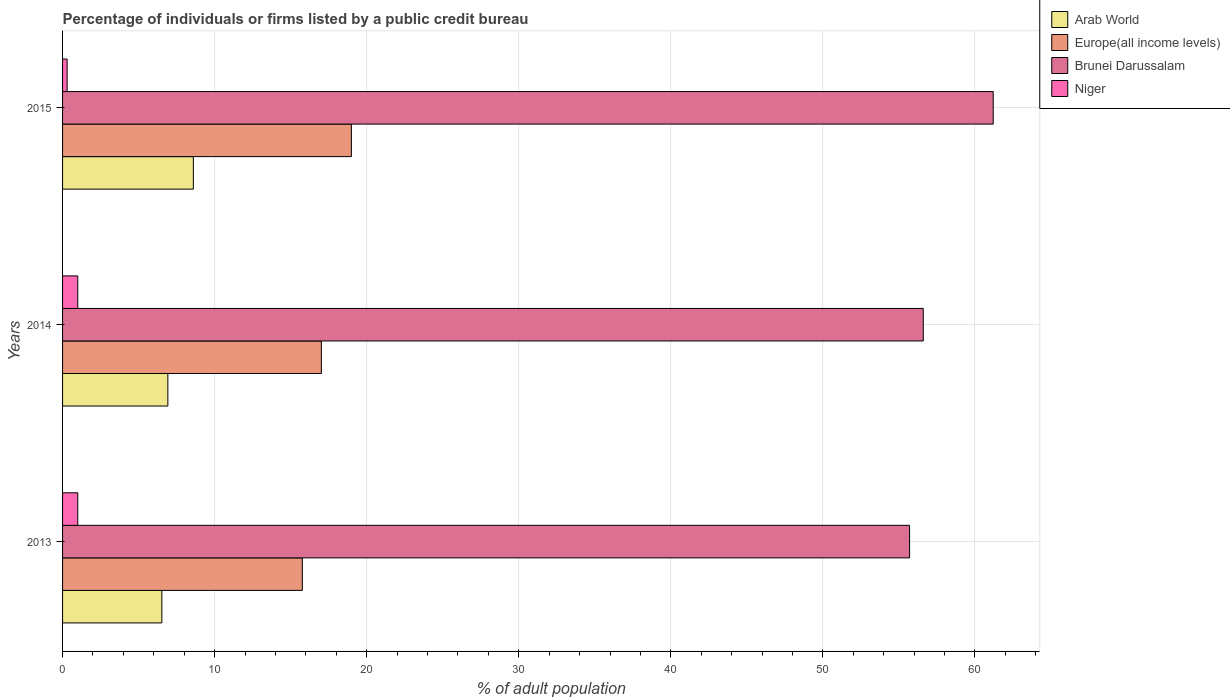Are the number of bars on each tick of the Y-axis equal?
Give a very brief answer. Yes. How many bars are there on the 1st tick from the bottom?
Offer a terse response. 4. In how many cases, is the number of bars for a given year not equal to the number of legend labels?
Give a very brief answer. 0. What is the percentage of population listed by a public credit bureau in Brunei Darussalam in 2013?
Provide a short and direct response. 55.7. Across all years, what is the maximum percentage of population listed by a public credit bureau in Europe(all income levels)?
Your answer should be compact. 18.99. Across all years, what is the minimum percentage of population listed by a public credit bureau in Europe(all income levels)?
Ensure brevity in your answer.  15.77. In which year was the percentage of population listed by a public credit bureau in Arab World maximum?
Provide a succinct answer. 2015. In which year was the percentage of population listed by a public credit bureau in Niger minimum?
Offer a terse response. 2015. What is the total percentage of population listed by a public credit bureau in Brunei Darussalam in the graph?
Provide a succinct answer. 173.5. What is the difference between the percentage of population listed by a public credit bureau in Europe(all income levels) in 2013 and that in 2015?
Provide a short and direct response. -3.23. What is the average percentage of population listed by a public credit bureau in Arab World per year?
Give a very brief answer. 7.35. In the year 2015, what is the difference between the percentage of population listed by a public credit bureau in Europe(all income levels) and percentage of population listed by a public credit bureau in Arab World?
Offer a terse response. 10.39. In how many years, is the percentage of population listed by a public credit bureau in Arab World greater than 22 %?
Provide a succinct answer. 0. What is the ratio of the percentage of population listed by a public credit bureau in Brunei Darussalam in 2014 to that in 2015?
Offer a terse response. 0.92. Is the percentage of population listed by a public credit bureau in Europe(all income levels) in 2013 less than that in 2014?
Your response must be concise. Yes. What is the difference between the highest and the second highest percentage of population listed by a public credit bureau in Europe(all income levels)?
Your response must be concise. 1.98. What is the difference between the highest and the lowest percentage of population listed by a public credit bureau in Brunei Darussalam?
Offer a terse response. 5.5. In how many years, is the percentage of population listed by a public credit bureau in Europe(all income levels) greater than the average percentage of population listed by a public credit bureau in Europe(all income levels) taken over all years?
Your response must be concise. 1. Is it the case that in every year, the sum of the percentage of population listed by a public credit bureau in Brunei Darussalam and percentage of population listed by a public credit bureau in Niger is greater than the sum of percentage of population listed by a public credit bureau in Europe(all income levels) and percentage of population listed by a public credit bureau in Arab World?
Provide a short and direct response. Yes. What does the 3rd bar from the top in 2015 represents?
Your answer should be compact. Europe(all income levels). What does the 3rd bar from the bottom in 2014 represents?
Your answer should be very brief. Brunei Darussalam. Is it the case that in every year, the sum of the percentage of population listed by a public credit bureau in Europe(all income levels) and percentage of population listed by a public credit bureau in Arab World is greater than the percentage of population listed by a public credit bureau in Niger?
Ensure brevity in your answer.  Yes. How many bars are there?
Your response must be concise. 12. Are all the bars in the graph horizontal?
Offer a very short reply. Yes. How many years are there in the graph?
Offer a very short reply. 3. What is the difference between two consecutive major ticks on the X-axis?
Offer a very short reply. 10. Are the values on the major ticks of X-axis written in scientific E-notation?
Give a very brief answer. No. Does the graph contain grids?
Your response must be concise. Yes. What is the title of the graph?
Offer a very short reply. Percentage of individuals or firms listed by a public credit bureau. Does "Swaziland" appear as one of the legend labels in the graph?
Your answer should be very brief. No. What is the label or title of the X-axis?
Offer a very short reply. % of adult population. What is the label or title of the Y-axis?
Your answer should be very brief. Years. What is the % of adult population in Arab World in 2013?
Make the answer very short. 6.53. What is the % of adult population in Europe(all income levels) in 2013?
Ensure brevity in your answer.  15.77. What is the % of adult population in Brunei Darussalam in 2013?
Give a very brief answer. 55.7. What is the % of adult population of Arab World in 2014?
Your answer should be very brief. 6.92. What is the % of adult population in Europe(all income levels) in 2014?
Give a very brief answer. 17.02. What is the % of adult population of Brunei Darussalam in 2014?
Ensure brevity in your answer.  56.6. What is the % of adult population of Niger in 2014?
Your response must be concise. 1. What is the % of adult population in Arab World in 2015?
Provide a succinct answer. 8.6. What is the % of adult population of Europe(all income levels) in 2015?
Keep it short and to the point. 18.99. What is the % of adult population of Brunei Darussalam in 2015?
Your answer should be very brief. 61.2. Across all years, what is the maximum % of adult population of Europe(all income levels)?
Make the answer very short. 18.99. Across all years, what is the maximum % of adult population of Brunei Darussalam?
Make the answer very short. 61.2. Across all years, what is the minimum % of adult population in Arab World?
Provide a short and direct response. 6.53. Across all years, what is the minimum % of adult population of Europe(all income levels)?
Ensure brevity in your answer.  15.77. Across all years, what is the minimum % of adult population of Brunei Darussalam?
Your response must be concise. 55.7. Across all years, what is the minimum % of adult population in Niger?
Your answer should be compact. 0.3. What is the total % of adult population of Arab World in the graph?
Give a very brief answer. 22.05. What is the total % of adult population in Europe(all income levels) in the graph?
Offer a very short reply. 51.78. What is the total % of adult population in Brunei Darussalam in the graph?
Offer a terse response. 173.5. What is the difference between the % of adult population of Arab World in 2013 and that in 2014?
Your answer should be compact. -0.4. What is the difference between the % of adult population in Europe(all income levels) in 2013 and that in 2014?
Your answer should be compact. -1.25. What is the difference between the % of adult population of Brunei Darussalam in 2013 and that in 2014?
Offer a terse response. -0.9. What is the difference between the % of adult population in Arab World in 2013 and that in 2015?
Offer a terse response. -2.07. What is the difference between the % of adult population of Europe(all income levels) in 2013 and that in 2015?
Give a very brief answer. -3.23. What is the difference between the % of adult population in Niger in 2013 and that in 2015?
Provide a short and direct response. 0.7. What is the difference between the % of adult population in Arab World in 2014 and that in 2015?
Provide a succinct answer. -1.68. What is the difference between the % of adult population in Europe(all income levels) in 2014 and that in 2015?
Ensure brevity in your answer.  -1.98. What is the difference between the % of adult population of Niger in 2014 and that in 2015?
Your answer should be very brief. 0.7. What is the difference between the % of adult population of Arab World in 2013 and the % of adult population of Europe(all income levels) in 2014?
Offer a terse response. -10.49. What is the difference between the % of adult population of Arab World in 2013 and the % of adult population of Brunei Darussalam in 2014?
Your answer should be very brief. -50.07. What is the difference between the % of adult population of Arab World in 2013 and the % of adult population of Niger in 2014?
Provide a short and direct response. 5.53. What is the difference between the % of adult population in Europe(all income levels) in 2013 and the % of adult population in Brunei Darussalam in 2014?
Your answer should be very brief. -40.83. What is the difference between the % of adult population of Europe(all income levels) in 2013 and the % of adult population of Niger in 2014?
Offer a very short reply. 14.77. What is the difference between the % of adult population of Brunei Darussalam in 2013 and the % of adult population of Niger in 2014?
Ensure brevity in your answer.  54.7. What is the difference between the % of adult population of Arab World in 2013 and the % of adult population of Europe(all income levels) in 2015?
Your answer should be compact. -12.47. What is the difference between the % of adult population of Arab World in 2013 and the % of adult population of Brunei Darussalam in 2015?
Provide a succinct answer. -54.67. What is the difference between the % of adult population of Arab World in 2013 and the % of adult population of Niger in 2015?
Offer a very short reply. 6.23. What is the difference between the % of adult population in Europe(all income levels) in 2013 and the % of adult population in Brunei Darussalam in 2015?
Provide a succinct answer. -45.43. What is the difference between the % of adult population of Europe(all income levels) in 2013 and the % of adult population of Niger in 2015?
Your response must be concise. 15.47. What is the difference between the % of adult population of Brunei Darussalam in 2013 and the % of adult population of Niger in 2015?
Provide a succinct answer. 55.4. What is the difference between the % of adult population in Arab World in 2014 and the % of adult population in Europe(all income levels) in 2015?
Provide a short and direct response. -12.07. What is the difference between the % of adult population in Arab World in 2014 and the % of adult population in Brunei Darussalam in 2015?
Ensure brevity in your answer.  -54.28. What is the difference between the % of adult population in Arab World in 2014 and the % of adult population in Niger in 2015?
Keep it short and to the point. 6.62. What is the difference between the % of adult population in Europe(all income levels) in 2014 and the % of adult population in Brunei Darussalam in 2015?
Your answer should be compact. -44.18. What is the difference between the % of adult population in Europe(all income levels) in 2014 and the % of adult population in Niger in 2015?
Offer a terse response. 16.72. What is the difference between the % of adult population in Brunei Darussalam in 2014 and the % of adult population in Niger in 2015?
Your answer should be very brief. 56.3. What is the average % of adult population in Arab World per year?
Keep it short and to the point. 7.35. What is the average % of adult population in Europe(all income levels) per year?
Provide a short and direct response. 17.26. What is the average % of adult population of Brunei Darussalam per year?
Make the answer very short. 57.83. What is the average % of adult population in Niger per year?
Offer a terse response. 0.77. In the year 2013, what is the difference between the % of adult population of Arab World and % of adult population of Europe(all income levels)?
Your answer should be very brief. -9.24. In the year 2013, what is the difference between the % of adult population in Arab World and % of adult population in Brunei Darussalam?
Ensure brevity in your answer.  -49.17. In the year 2013, what is the difference between the % of adult population of Arab World and % of adult population of Niger?
Your response must be concise. 5.53. In the year 2013, what is the difference between the % of adult population in Europe(all income levels) and % of adult population in Brunei Darussalam?
Ensure brevity in your answer.  -39.93. In the year 2013, what is the difference between the % of adult population in Europe(all income levels) and % of adult population in Niger?
Make the answer very short. 14.77. In the year 2013, what is the difference between the % of adult population of Brunei Darussalam and % of adult population of Niger?
Your answer should be compact. 54.7. In the year 2014, what is the difference between the % of adult population in Arab World and % of adult population in Europe(all income levels)?
Your response must be concise. -10.09. In the year 2014, what is the difference between the % of adult population in Arab World and % of adult population in Brunei Darussalam?
Keep it short and to the point. -49.68. In the year 2014, what is the difference between the % of adult population of Arab World and % of adult population of Niger?
Ensure brevity in your answer.  5.92. In the year 2014, what is the difference between the % of adult population of Europe(all income levels) and % of adult population of Brunei Darussalam?
Provide a short and direct response. -39.58. In the year 2014, what is the difference between the % of adult population of Europe(all income levels) and % of adult population of Niger?
Your response must be concise. 16.02. In the year 2014, what is the difference between the % of adult population in Brunei Darussalam and % of adult population in Niger?
Ensure brevity in your answer.  55.6. In the year 2015, what is the difference between the % of adult population in Arab World and % of adult population in Europe(all income levels)?
Make the answer very short. -10.39. In the year 2015, what is the difference between the % of adult population of Arab World and % of adult population of Brunei Darussalam?
Provide a short and direct response. -52.6. In the year 2015, what is the difference between the % of adult population in Arab World and % of adult population in Niger?
Your response must be concise. 8.3. In the year 2015, what is the difference between the % of adult population in Europe(all income levels) and % of adult population in Brunei Darussalam?
Your response must be concise. -42.21. In the year 2015, what is the difference between the % of adult population in Europe(all income levels) and % of adult population in Niger?
Keep it short and to the point. 18.69. In the year 2015, what is the difference between the % of adult population of Brunei Darussalam and % of adult population of Niger?
Your answer should be very brief. 60.9. What is the ratio of the % of adult population in Arab World in 2013 to that in 2014?
Provide a short and direct response. 0.94. What is the ratio of the % of adult population in Europe(all income levels) in 2013 to that in 2014?
Make the answer very short. 0.93. What is the ratio of the % of adult population in Brunei Darussalam in 2013 to that in 2014?
Offer a very short reply. 0.98. What is the ratio of the % of adult population in Niger in 2013 to that in 2014?
Your answer should be very brief. 1. What is the ratio of the % of adult population of Arab World in 2013 to that in 2015?
Your answer should be very brief. 0.76. What is the ratio of the % of adult population in Europe(all income levels) in 2013 to that in 2015?
Your answer should be very brief. 0.83. What is the ratio of the % of adult population in Brunei Darussalam in 2013 to that in 2015?
Make the answer very short. 0.91. What is the ratio of the % of adult population in Arab World in 2014 to that in 2015?
Your answer should be very brief. 0.81. What is the ratio of the % of adult population of Europe(all income levels) in 2014 to that in 2015?
Offer a terse response. 0.9. What is the ratio of the % of adult population of Brunei Darussalam in 2014 to that in 2015?
Keep it short and to the point. 0.92. What is the ratio of the % of adult population of Niger in 2014 to that in 2015?
Make the answer very short. 3.33. What is the difference between the highest and the second highest % of adult population in Arab World?
Ensure brevity in your answer.  1.68. What is the difference between the highest and the second highest % of adult population in Europe(all income levels)?
Make the answer very short. 1.98. What is the difference between the highest and the lowest % of adult population in Arab World?
Provide a short and direct response. 2.07. What is the difference between the highest and the lowest % of adult population of Europe(all income levels)?
Your answer should be compact. 3.23. 